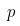Convert formula to latex. <formula><loc_0><loc_0><loc_500><loc_500>p</formula> 